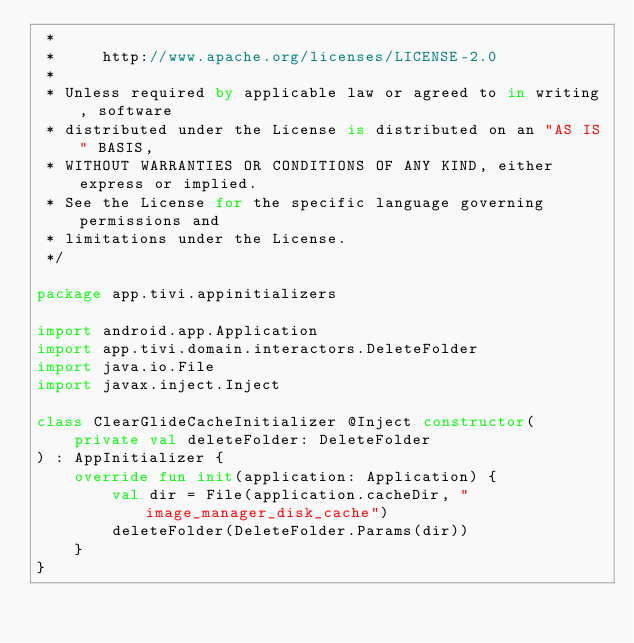<code> <loc_0><loc_0><loc_500><loc_500><_Kotlin_> *
 *     http://www.apache.org/licenses/LICENSE-2.0
 *
 * Unless required by applicable law or agreed to in writing, software
 * distributed under the License is distributed on an "AS IS" BASIS,
 * WITHOUT WARRANTIES OR CONDITIONS OF ANY KIND, either express or implied.
 * See the License for the specific language governing permissions and
 * limitations under the License.
 */

package app.tivi.appinitializers

import android.app.Application
import app.tivi.domain.interactors.DeleteFolder
import java.io.File
import javax.inject.Inject

class ClearGlideCacheInitializer @Inject constructor(
    private val deleteFolder: DeleteFolder
) : AppInitializer {
    override fun init(application: Application) {
        val dir = File(application.cacheDir, "image_manager_disk_cache")
        deleteFolder(DeleteFolder.Params(dir))
    }
}</code> 